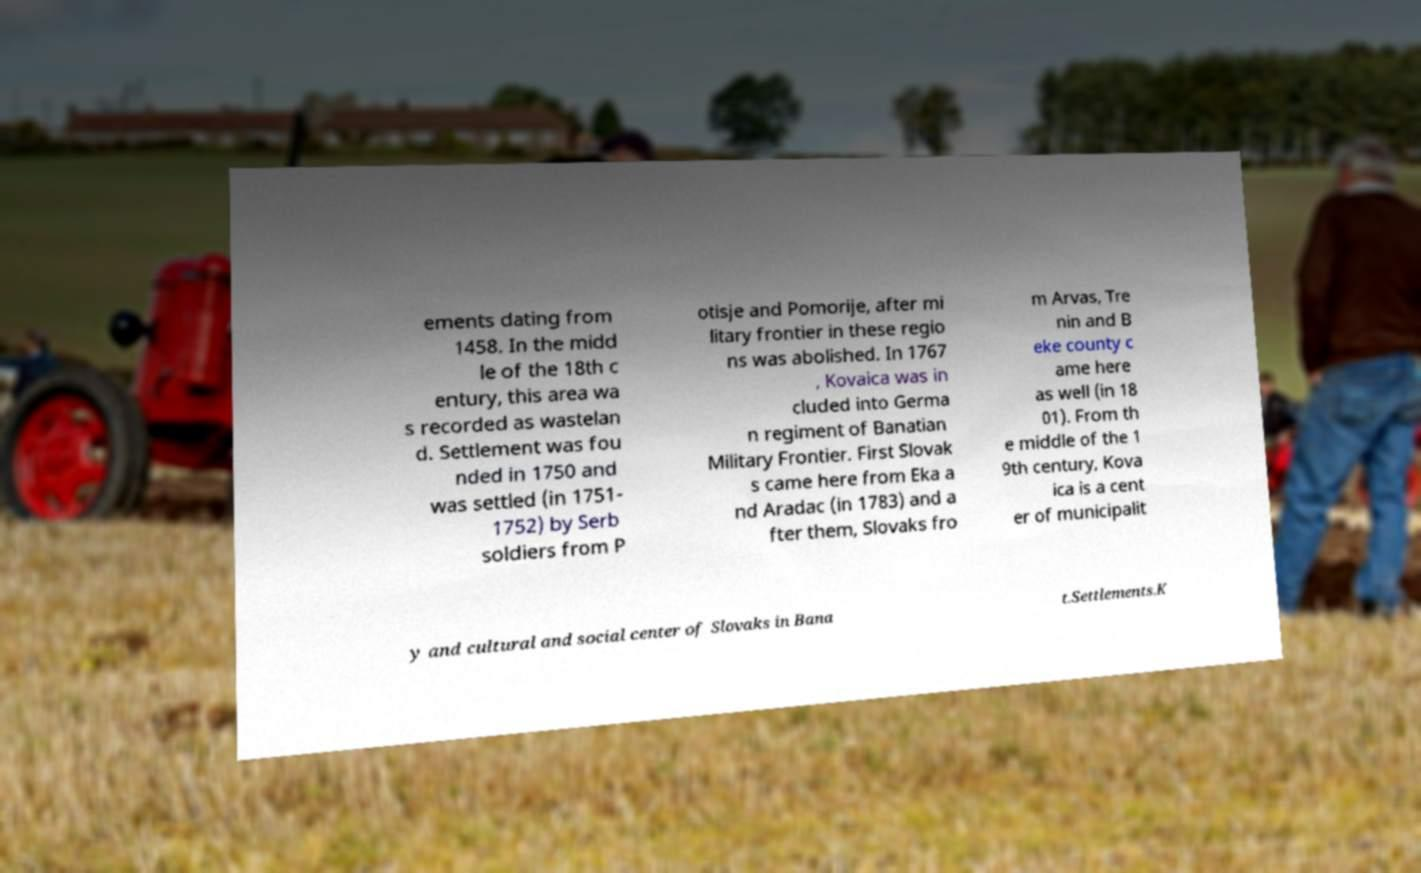What messages or text are displayed in this image? I need them in a readable, typed format. ements dating from 1458. In the midd le of the 18th c entury, this area wa s recorded as wastelan d. Settlement was fou nded in 1750 and was settled (in 1751- 1752) by Serb soldiers from P otisje and Pomorije, after mi litary frontier in these regio ns was abolished. In 1767 , Kovaica was in cluded into Germa n regiment of Banatian Military Frontier. First Slovak s came here from Eka a nd Aradac (in 1783) and a fter them, Slovaks fro m Arvas, Tre nin and B eke county c ame here as well (in 18 01). From th e middle of the 1 9th century, Kova ica is a cent er of municipalit y and cultural and social center of Slovaks in Bana t.Settlements.K 